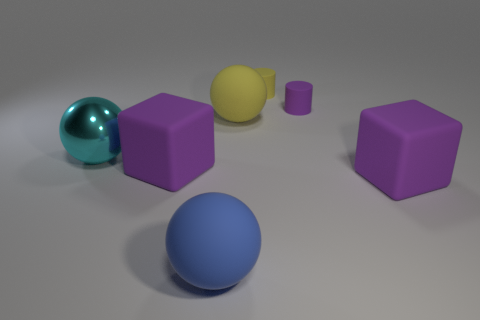Describe the lighting and shadows in the scene. The scene is lit from above, casting slight shadows beneath each object. These shadows help to give a sense of the objects' positions in three-dimensional space. 